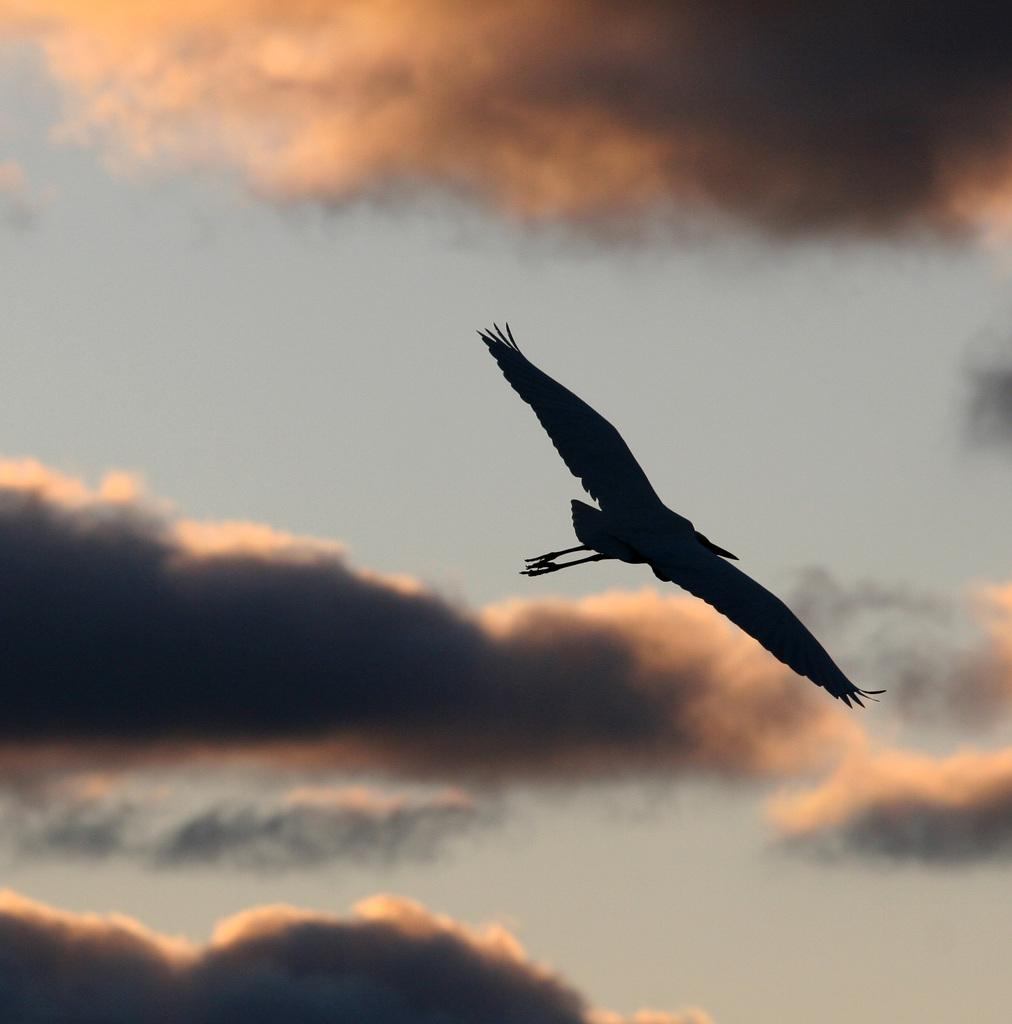What type of animal can be seen in the image? There is a bird in the image. What is the bird doing in the image? The bird is flying in the air. What can be seen in the background of the image? The sky is visible in the background of the image. How would you describe the sky in the image? The sky is cloudy in the image. What type of glue can be seen on the bird's wings in the image? There is no glue present on the bird's wings in the image. Is there a plant visible in the image? There is no plant visible in the image. Can you see any signs of a battle happening in the image? There is no indication of a battle happening in the image. 